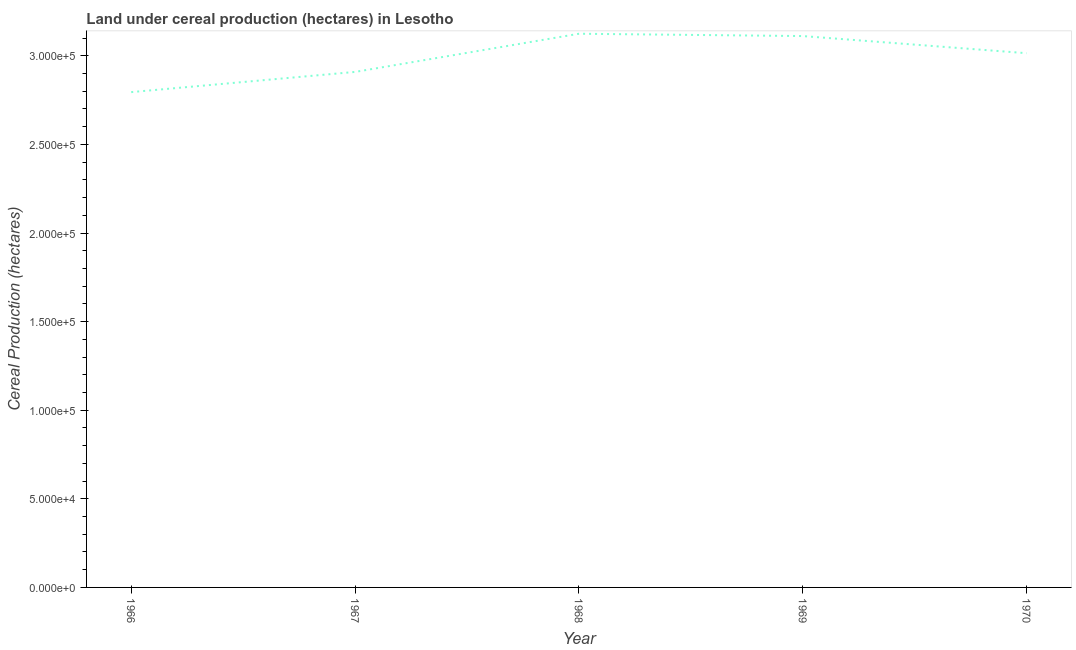What is the land under cereal production in 1968?
Make the answer very short. 3.12e+05. Across all years, what is the maximum land under cereal production?
Offer a terse response. 3.12e+05. Across all years, what is the minimum land under cereal production?
Ensure brevity in your answer.  2.80e+05. In which year was the land under cereal production maximum?
Your response must be concise. 1968. In which year was the land under cereal production minimum?
Your answer should be compact. 1966. What is the sum of the land under cereal production?
Offer a very short reply. 1.50e+06. What is the difference between the land under cereal production in 1966 and 1969?
Your answer should be very brief. -3.16e+04. What is the average land under cereal production per year?
Offer a very short reply. 2.99e+05. What is the median land under cereal production?
Make the answer very short. 3.01e+05. Do a majority of the years between 1968 and 1966 (inclusive) have land under cereal production greater than 260000 hectares?
Provide a short and direct response. No. What is the ratio of the land under cereal production in 1967 to that in 1969?
Offer a very short reply. 0.93. Is the land under cereal production in 1968 less than that in 1970?
Your answer should be compact. No. What is the difference between the highest and the second highest land under cereal production?
Your response must be concise. 1312. What is the difference between the highest and the lowest land under cereal production?
Your answer should be very brief. 3.29e+04. Does the land under cereal production monotonically increase over the years?
Ensure brevity in your answer.  No. How many lines are there?
Make the answer very short. 1. Does the graph contain grids?
Your answer should be very brief. No. What is the title of the graph?
Ensure brevity in your answer.  Land under cereal production (hectares) in Lesotho. What is the label or title of the Y-axis?
Make the answer very short. Cereal Production (hectares). What is the Cereal Production (hectares) of 1966?
Ensure brevity in your answer.  2.80e+05. What is the Cereal Production (hectares) in 1967?
Your response must be concise. 2.91e+05. What is the Cereal Production (hectares) in 1968?
Your answer should be very brief. 3.12e+05. What is the Cereal Production (hectares) in 1969?
Provide a short and direct response. 3.11e+05. What is the Cereal Production (hectares) in 1970?
Provide a succinct answer. 3.01e+05. What is the difference between the Cereal Production (hectares) in 1966 and 1967?
Ensure brevity in your answer.  -1.14e+04. What is the difference between the Cereal Production (hectares) in 1966 and 1968?
Offer a very short reply. -3.29e+04. What is the difference between the Cereal Production (hectares) in 1966 and 1969?
Give a very brief answer. -3.16e+04. What is the difference between the Cereal Production (hectares) in 1966 and 1970?
Offer a terse response. -2.20e+04. What is the difference between the Cereal Production (hectares) in 1967 and 1968?
Ensure brevity in your answer.  -2.15e+04. What is the difference between the Cereal Production (hectares) in 1967 and 1969?
Give a very brief answer. -2.02e+04. What is the difference between the Cereal Production (hectares) in 1967 and 1970?
Keep it short and to the point. -1.06e+04. What is the difference between the Cereal Production (hectares) in 1968 and 1969?
Ensure brevity in your answer.  1312. What is the difference between the Cereal Production (hectares) in 1968 and 1970?
Offer a very short reply. 1.10e+04. What is the difference between the Cereal Production (hectares) in 1969 and 1970?
Provide a succinct answer. 9672. What is the ratio of the Cereal Production (hectares) in 1966 to that in 1967?
Your response must be concise. 0.96. What is the ratio of the Cereal Production (hectares) in 1966 to that in 1968?
Offer a very short reply. 0.9. What is the ratio of the Cereal Production (hectares) in 1966 to that in 1969?
Your answer should be compact. 0.9. What is the ratio of the Cereal Production (hectares) in 1966 to that in 1970?
Provide a succinct answer. 0.93. What is the ratio of the Cereal Production (hectares) in 1967 to that in 1969?
Offer a terse response. 0.94. What is the ratio of the Cereal Production (hectares) in 1968 to that in 1969?
Ensure brevity in your answer.  1. What is the ratio of the Cereal Production (hectares) in 1968 to that in 1970?
Provide a short and direct response. 1.04. What is the ratio of the Cereal Production (hectares) in 1969 to that in 1970?
Your answer should be very brief. 1.03. 